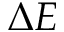<formula> <loc_0><loc_0><loc_500><loc_500>\Delta E</formula> 